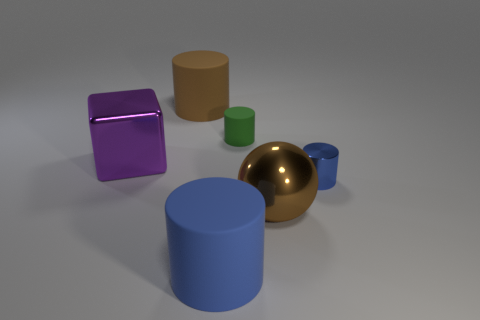How many small objects are either cylinders or green matte cylinders?
Ensure brevity in your answer.  2. What is the color of the tiny cylinder that is the same material as the brown sphere?
Ensure brevity in your answer.  Blue. There is a metal object behind the tiny shiny thing; does it have the same shape as the brown object that is to the left of the small green cylinder?
Give a very brief answer. No. How many matte objects are large blue objects or blue cylinders?
Your answer should be very brief. 1. Is there anything else that has the same shape as the big purple shiny object?
Offer a very short reply. No. There is a blue cylinder on the left side of the small green cylinder; what is its material?
Give a very brief answer. Rubber. Is the material of the brown thing that is left of the brown metallic thing the same as the big blue cylinder?
Give a very brief answer. Yes. What number of things are big purple metallic cylinders or brown objects to the left of the small green rubber cylinder?
Your answer should be compact. 1. What is the size of the green rubber thing that is the same shape as the blue rubber object?
Your answer should be compact. Small. Is there anything else that has the same size as the green matte object?
Provide a succinct answer. Yes. 